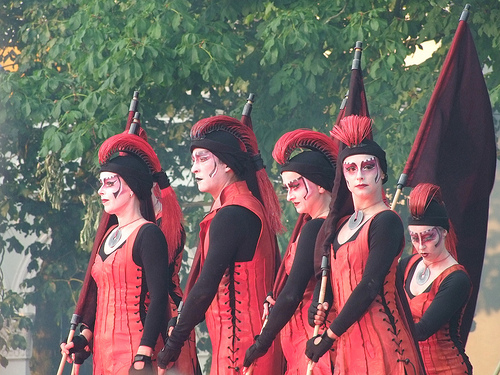<image>
Is there a woman to the left of the woman? Yes. From this viewpoint, the woman is positioned to the left side relative to the woman. Is the girl behind the girl? Yes. From this viewpoint, the girl is positioned behind the girl, with the girl partially or fully occluding the girl. Is there a girl in front of the girl? No. The girl is not in front of the girl. The spatial positioning shows a different relationship between these objects. 